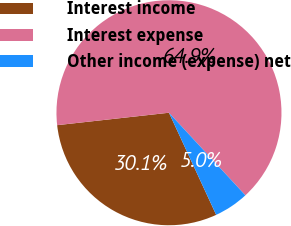<chart> <loc_0><loc_0><loc_500><loc_500><pie_chart><fcel>Interest income<fcel>Interest expense<fcel>Other income (expense) net<nl><fcel>30.13%<fcel>64.88%<fcel>4.99%<nl></chart> 